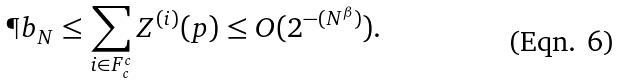<formula> <loc_0><loc_0><loc_500><loc_500>\P b _ { N } \leq \sum _ { i \in F _ { c } ^ { c } } Z ^ { ( i ) } ( p ) \leq O ( 2 ^ { - ( N ^ { \beta } ) } ) .</formula> 